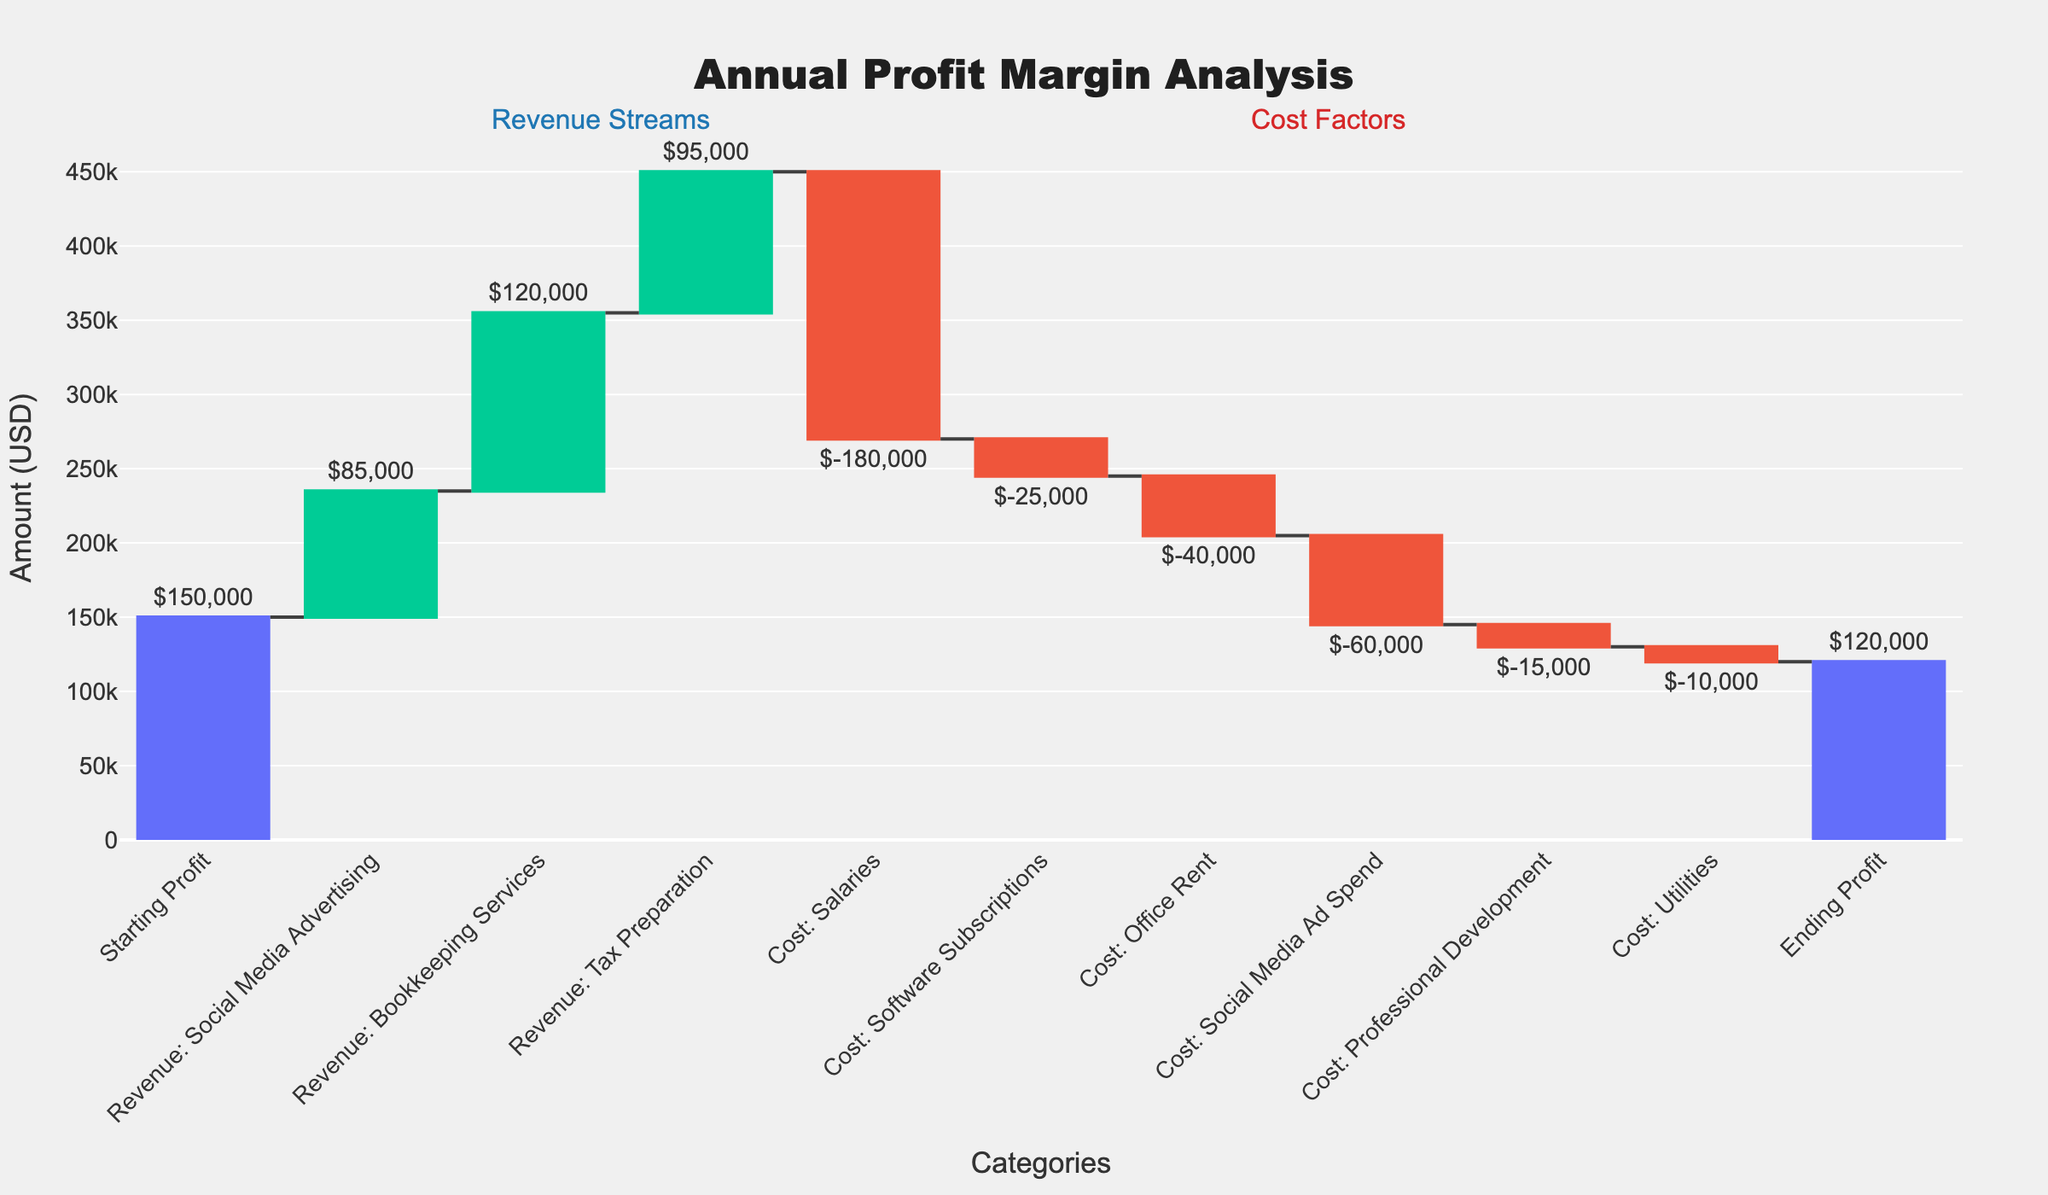What's the starting profit? The starting profit is shown as the first value in the waterfall chart.
Answer: $150,000 What is the Ending Profit? The ending profit is displayed as the last value in the waterfall chart.
Answer: $120,000 What is the total revenue from Social Media Advertising, Bookkeeping Services, and Tax Preparation combined? To find the total revenue, add the amounts from the three sources: $85,000 (Social Media Advertising) + $120,000 (Bookkeeping Services) + $95,000 (Tax Preparation).
Answer: $300,000 How much was spent on Office Rent? The cost for Office Rent is labeled in the chart.
Answer: $40,000 Which cost factor had the highest expense? The cost factor with the highest expense is Salaries, as indicated by the highest negative bar.
Answer: $180,000 What is the net profit change when you consider only the revenue streams? Sum the revenue from Social Media Advertising, Bookkeeping Services, and Tax Preparation: $85,000 + $120,000 + $95,000, which equals $300,000.
Answer: $300,000 How does the cost of Software Subscriptions compare to Professional Development? The cost of Software Subscriptions is $25,000, which is greater than Professional Development, which is $15,000.
Answer: $10,000 more If Social Media Ad Spend were reduced by 50%, what would the adjusted expense be for that category? Calculate 50% of Social Media Ad Spend ($60,000): $60,000 / 2 = $30,000.
Answer: $30,000 What is the total amount spent on costs? Sum all the costs: Salaries ($180,000) + Software Subscriptions ($25,000) + Office Rent ($40,000) + Social Media Ad Spend ($60,000) + Professional Development ($15,000) + Utilities ($10,000).
Answer: $330,000 What is the difference between the highest revenue stream and the highest cost factor? The highest revenue stream is Bookkeeping Services ($120,000) and the highest cost factor is Salaries ($180,000). Calculate the difference: $180,000 - $120,000.
Answer: $60,000 